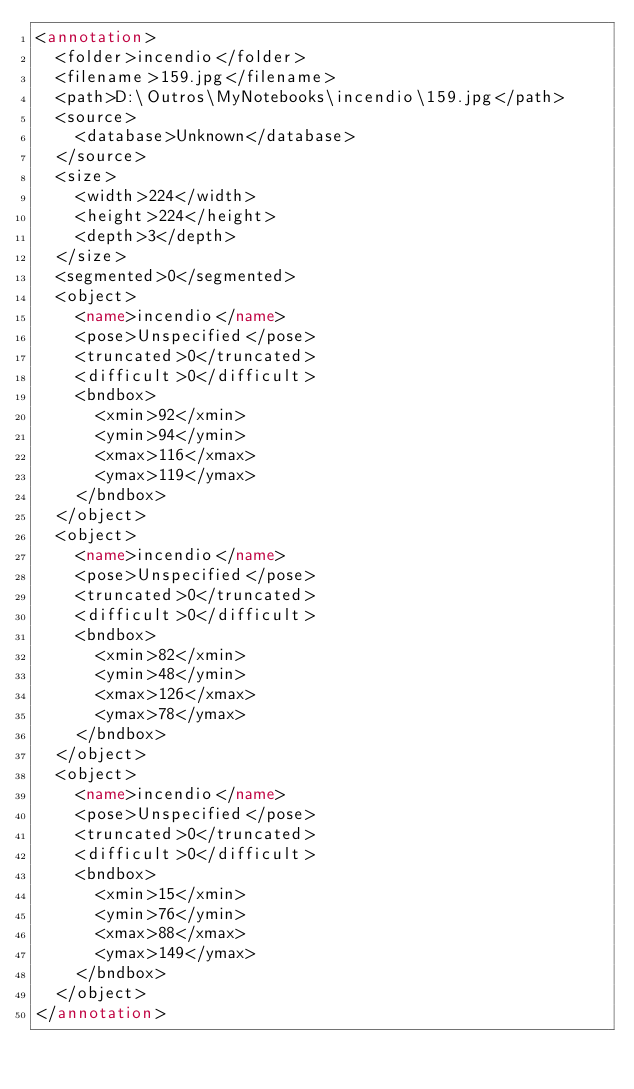<code> <loc_0><loc_0><loc_500><loc_500><_XML_><annotation>
	<folder>incendio</folder>
	<filename>159.jpg</filename>
	<path>D:\Outros\MyNotebooks\incendio\159.jpg</path>
	<source>
		<database>Unknown</database>
	</source>
	<size>
		<width>224</width>
		<height>224</height>
		<depth>3</depth>
	</size>
	<segmented>0</segmented>
	<object>
		<name>incendio</name>
		<pose>Unspecified</pose>
		<truncated>0</truncated>
		<difficult>0</difficult>
		<bndbox>
			<xmin>92</xmin>
			<ymin>94</ymin>
			<xmax>116</xmax>
			<ymax>119</ymax>
		</bndbox>
	</object>
	<object>
		<name>incendio</name>
		<pose>Unspecified</pose>
		<truncated>0</truncated>
		<difficult>0</difficult>
		<bndbox>
			<xmin>82</xmin>
			<ymin>48</ymin>
			<xmax>126</xmax>
			<ymax>78</ymax>
		</bndbox>
	</object>
	<object>
		<name>incendio</name>
		<pose>Unspecified</pose>
		<truncated>0</truncated>
		<difficult>0</difficult>
		<bndbox>
			<xmin>15</xmin>
			<ymin>76</ymin>
			<xmax>88</xmax>
			<ymax>149</ymax>
		</bndbox>
	</object>
</annotation>
</code> 